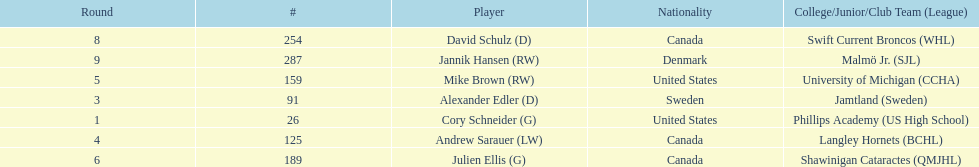Parse the full table. {'header': ['Round', '#', 'Player', 'Nationality', 'College/Junior/Club Team (League)'], 'rows': [['8', '254', 'David Schulz (D)', 'Canada', 'Swift Current Broncos (WHL)'], ['9', '287', 'Jannik Hansen (RW)', 'Denmark', 'Malmö Jr. (SJL)'], ['5', '159', 'Mike Brown (RW)', 'United States', 'University of Michigan (CCHA)'], ['3', '91', 'Alexander Edler (D)', 'Sweden', 'Jamtland (Sweden)'], ['1', '26', 'Cory Schneider (G)', 'United States', 'Phillips Academy (US High School)'], ['4', '125', 'Andrew Sarauer (LW)', 'Canada', 'Langley Hornets (BCHL)'], ['6', '189', 'Julien Ellis (G)', 'Canada', 'Shawinigan Cataractes (QMJHL)']]} Who were the players in the 2004-05 vancouver canucks season Cory Schneider (G), Alexander Edler (D), Andrew Sarauer (LW), Mike Brown (RW), Julien Ellis (G), David Schulz (D), Jannik Hansen (RW). Of these players who had a nationality of denmark? Jannik Hansen (RW). 